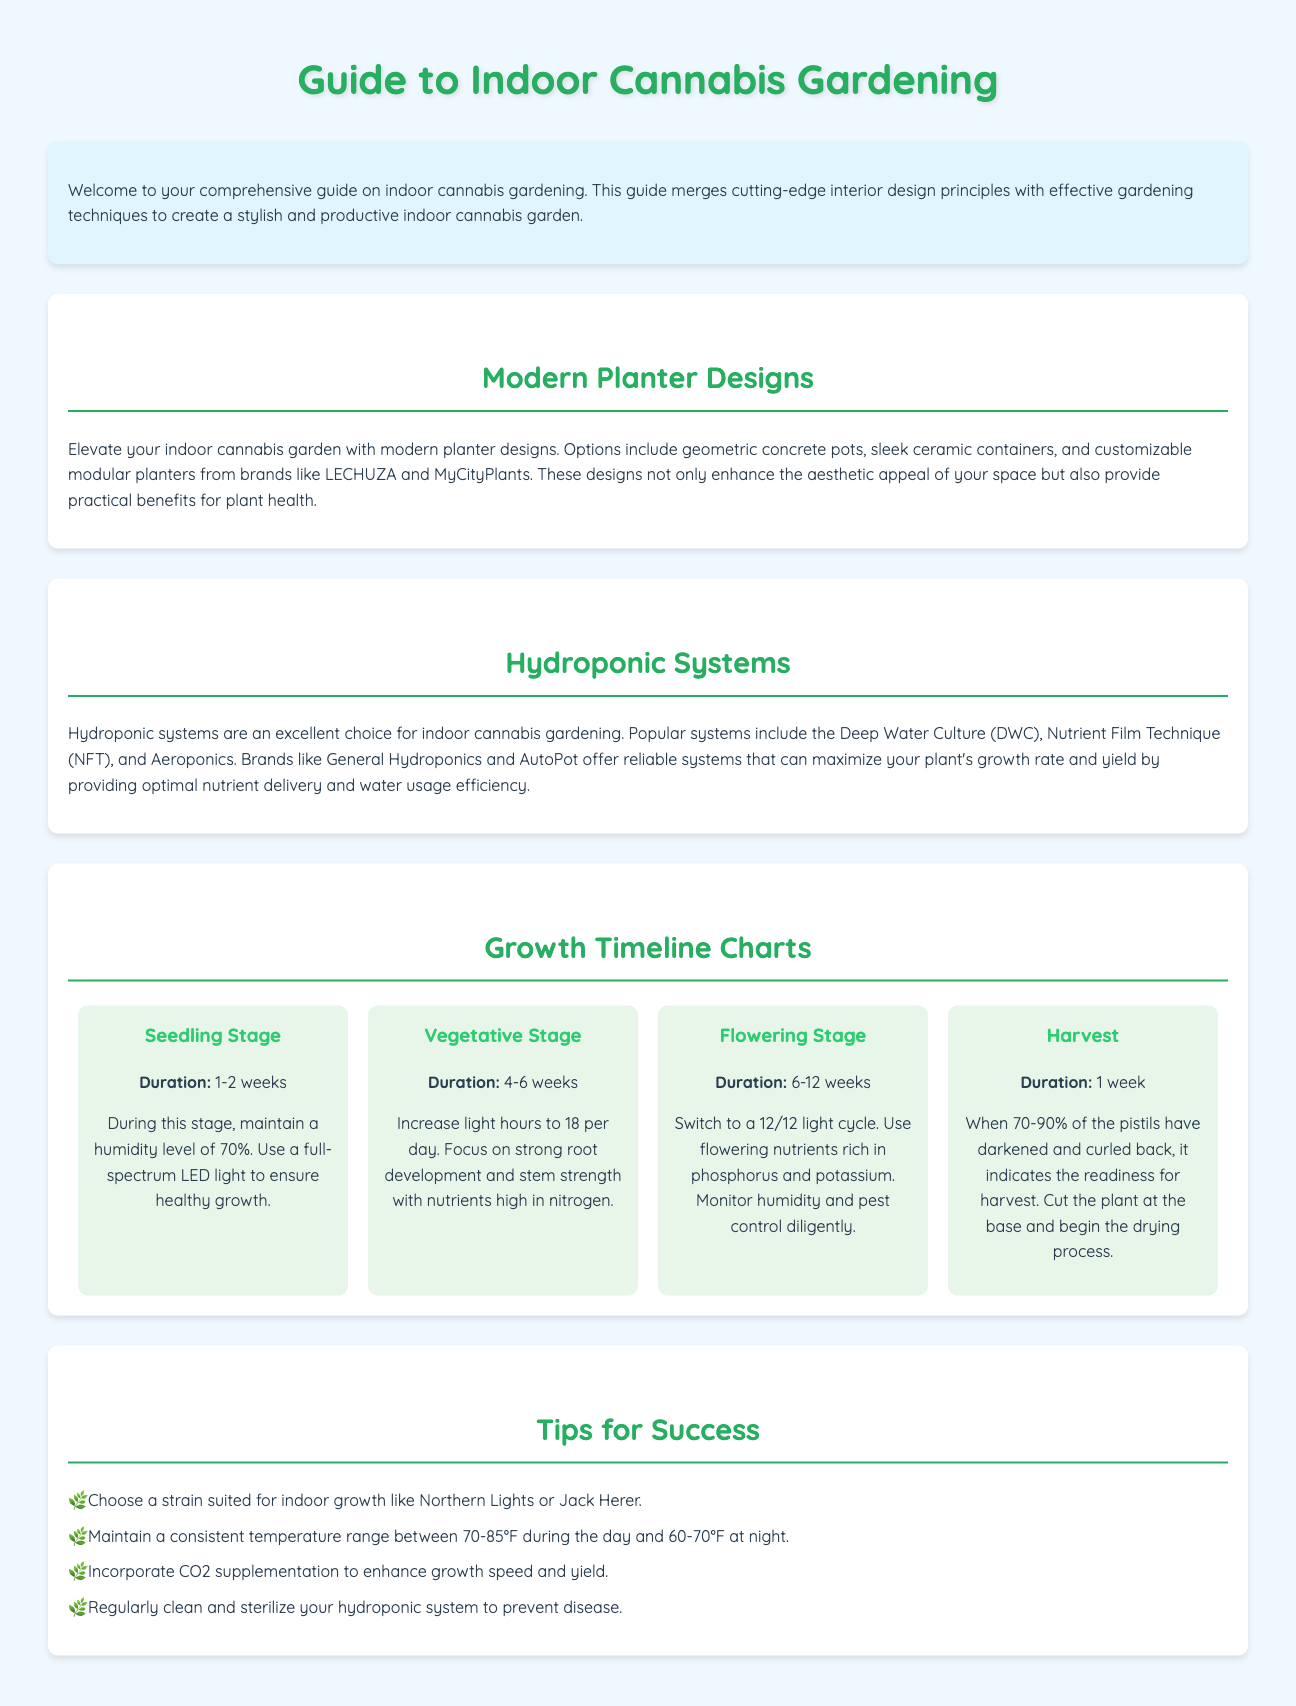What is the title of the guide? The title of the guide is mentioned at the top of the document.
Answer: Guide to Indoor Cannabis Gardening How long does the seedling stage last? The duration of the seedling stage is specified in the growth timeline section.
Answer: 1-2 weeks What light cycle should be used during the flowering stage? The document instructs to switch to a specific light cycle during the flowering stage.
Answer: 12/12 Which brand is mentioned for hydroponic systems? The guide lists certain brands associated with hydroponic systems in the document.
Answer: General Hydroponics What design style is recommended for indoor cannabis gardens? The document discusses design principles that should be integrated into indoor gardening.
Answer: Modern planter designs What nutrient should be high during the vegetative stage? The document specifies the type of nutrients needed for strong root development during a certain growth stage.
Answer: Nitrogen What is a tip for success in indoor cannabis gardening? The guide includes specific tips for successful indoor cannabis gardening.
Answer: Choose a strain suited for indoor growth What is the color theme of the document's headers? The color of the headers is mentioned, indicating the aesthetic choices made in the document.
Answer: Green 